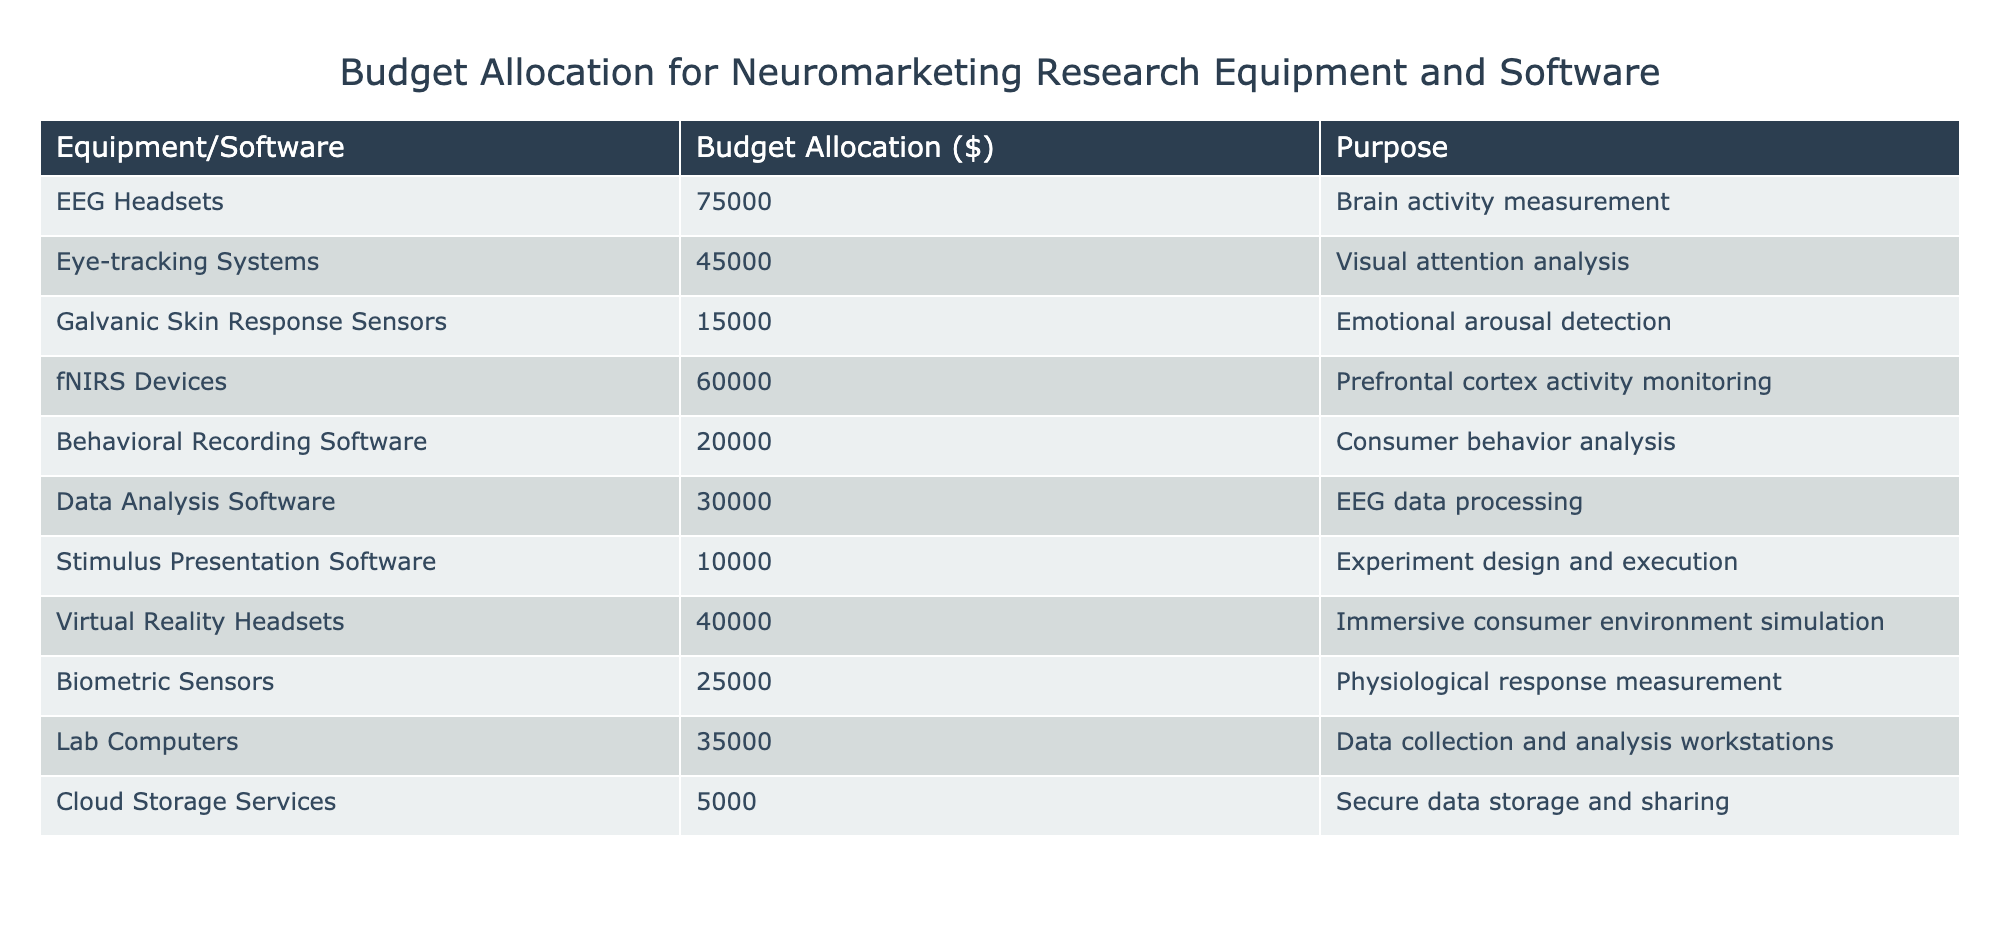What is the budget allocation for EEG headsets? The table specifies that the budget allocation for EEG headsets is listed directly under the corresponding column. Referring to the table, the value is $75,000.
Answer: 75000 What is the purpose of eye-tracking systems? According to the table, the purpose of eye-tracking systems is stated in the corresponding column next to its budget allocation. It is to perform visual attention analysis.
Answer: Visual attention analysis What is the total budget allocated for biometric sensors and galvanic skin response sensors combined? To find the total, we first identify the budget for biometric sensors, which is $25,000, and galvanic skin response sensors, which is $15,000. Adding these two amounts gives us $25,000 + $15,000 = $40,000.
Answer: 40000 Is the budget for cloud storage services higher than $10,000? Referring to the table, the budget allocation for cloud storage services is $5,000. Since this is less than $10,000, the answer is no.
Answer: No Which two equipment pieces have a budget higher than $50,000? We need to look at the budget allocations and identify any equipment with amounts exceeding $50,000. From the table, EEG headsets ($75,000) and fNIRS devices ($60,000) meet this criterion. Therefore, those two are the answer.
Answer: EEG headsets and fNIRS devices What is the average budget allocation for the equipment and software listed in the table? First, we calculate the total budget by adding all the individual allocations: $75,000 + $45,000 + $15,000 + $60,000 + $20,000 + $30,000 + $10,000 + $40,000 + $25,000 + $35,000 + $5,000 = $435,000. There are 11 items in total, so the average will be $435,000 divided by 11, which equals approximately $39,545.45.
Answer: 39545.45 Does behavioral recording software have a lower budget allocation than virtual reality headsets? Checking the individual budget allocations, we find that behavioral recording software is allocated $20,000 and virtual reality headsets are allocated $40,000. Since $20,000 is less than $40,000, the answer is yes.
Answer: Yes How much more is allocated to fNIRS devices compared to eye-tracking systems? The allocation for fNIRS devices is $60,000 while eye-tracking systems have $45,000. To find the difference, we subtract $45,000 from $60,000, yielding $15,000.
Answer: 15000 Which equipment has the lowest budget allocation? We examine the budget allocations in the table and find that the lowest is for cloud storage services, which is $5,000.
Answer: 5000 